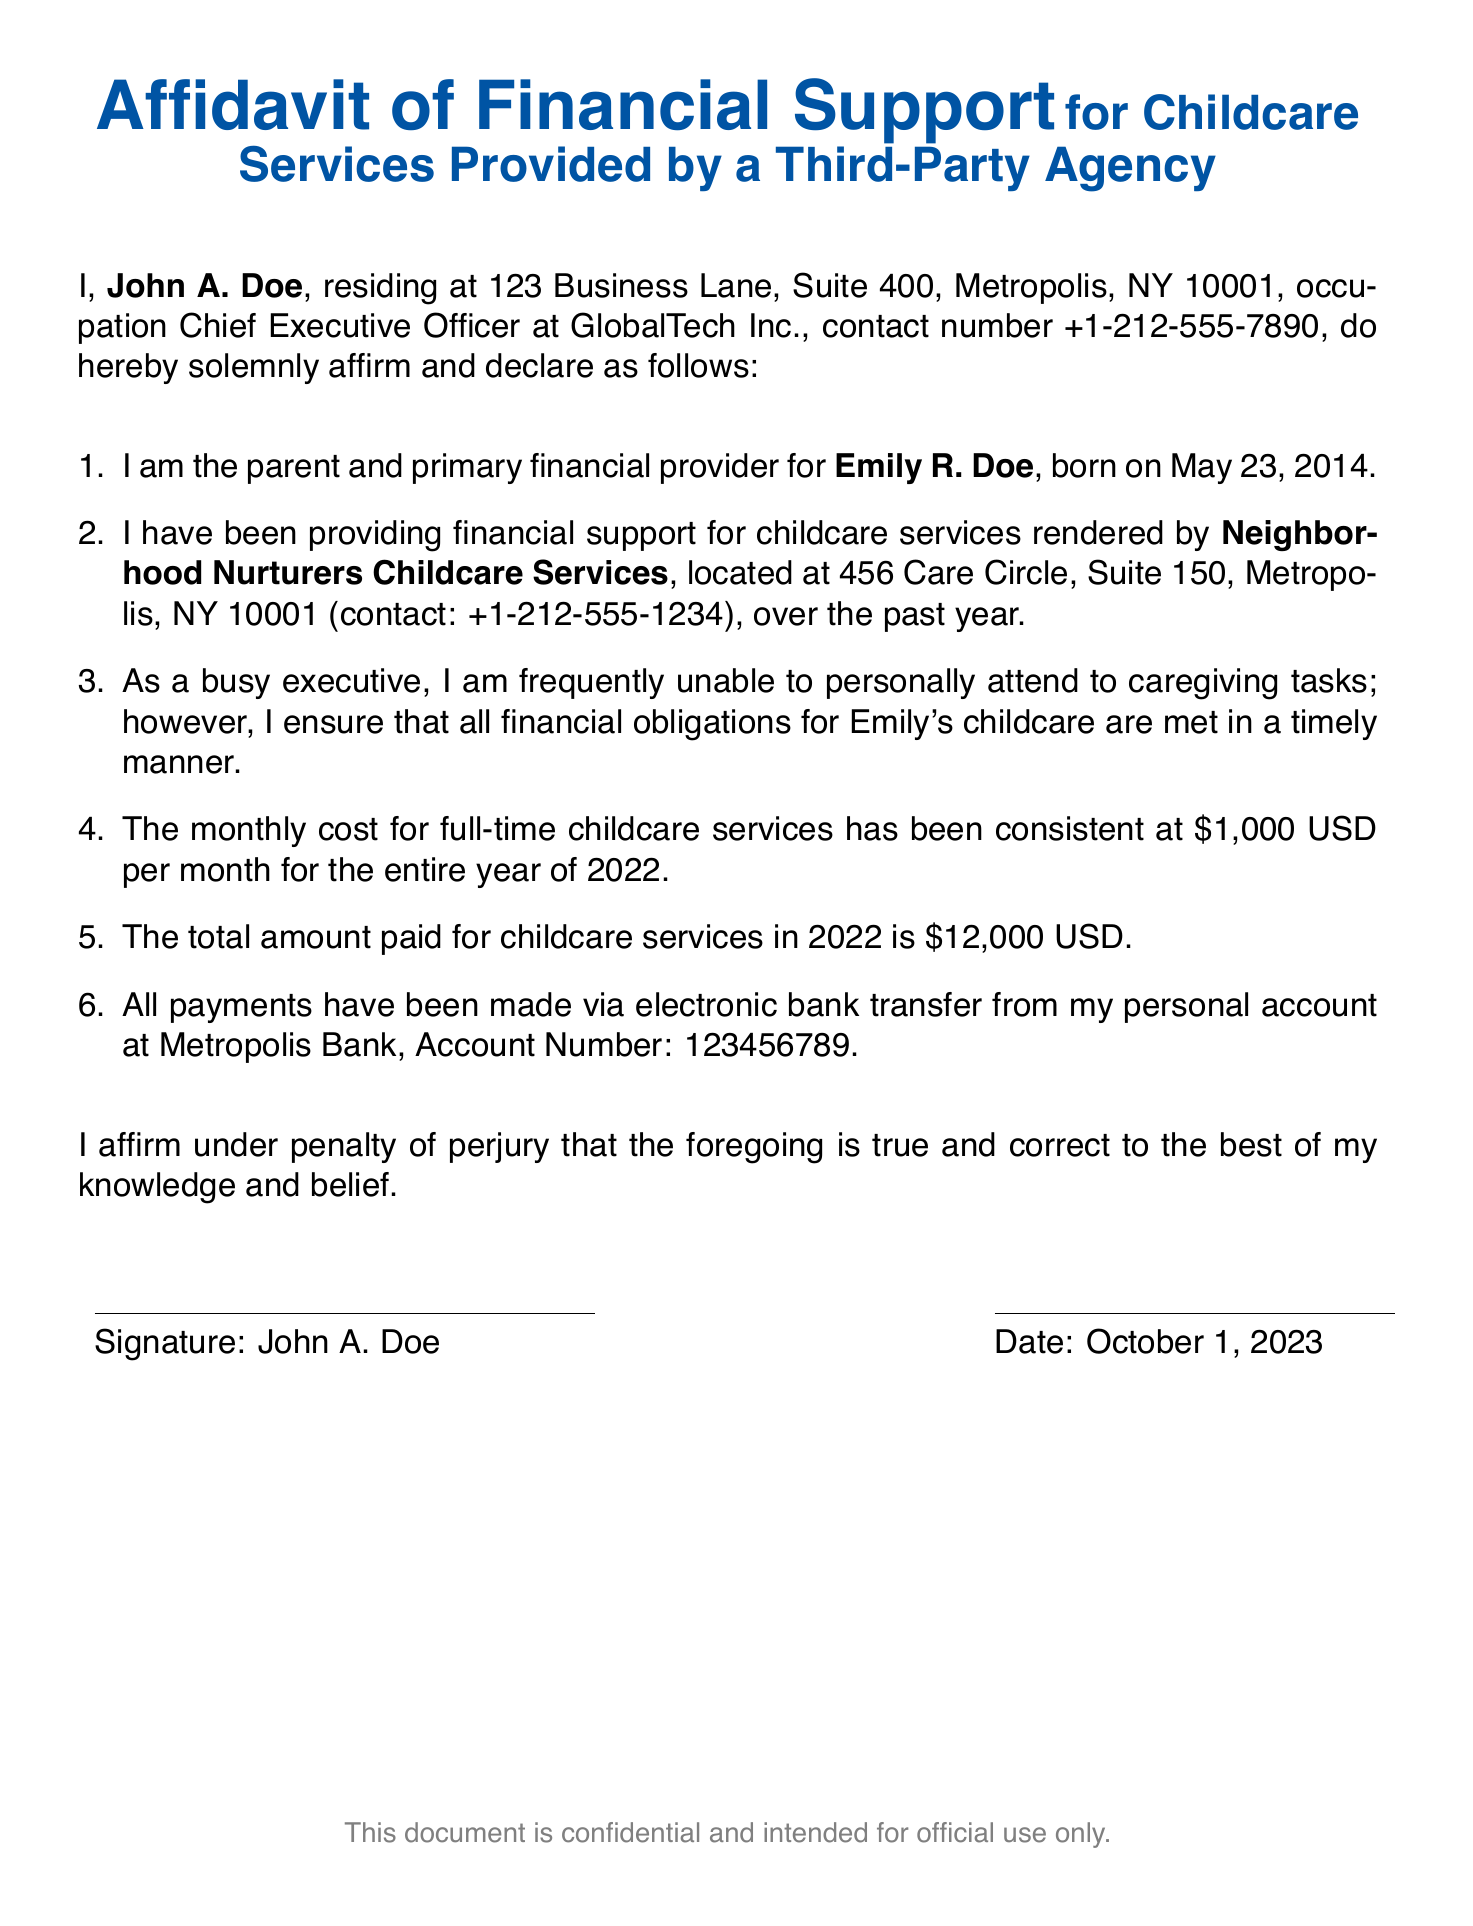What is the name of the child? The document states the child's name as Emily R. Doe.
Answer: Emily R. Doe Who is the primary financial provider? The affidavit identifies John A. Doe as the primary financial provider.
Answer: John A. Doe What is the monthly cost of childcare services? According to the document, the monthly cost is consistently $1,000 USD.
Answer: $1,000 USD What is the total amount paid for childcare services in 2022? The total amount stated in the document for 2022 is $12,000 USD.
Answer: $12,000 USD Who provides the childcare services? The affidavit mentions Neighborhood Nurturers Childcare Services as the provider.
Answer: Neighborhood Nurturers Childcare Services How often has payment been made? The document implies monthly payments have been made consistently throughout the year.
Answer: Monthly What is the date of the affidavit? The date mentioned in the document is October 1, 2023.
Answer: October 1, 2023 What is John A. Doe's occupation? The affidavit states his occupation as Chief Executive Officer at GlobalTech Inc.
Answer: Chief Executive Officer Where is the childcare service located? The document provides the address as 456 Care Circle, Suite 150, Metropolis, NY 10001.
Answer: 456 Care Circle, Suite 150, Metropolis, NY 10001 What method was used for payments? The affidavit specifies that payments were made via electronic bank transfer.
Answer: Electronic bank transfer 